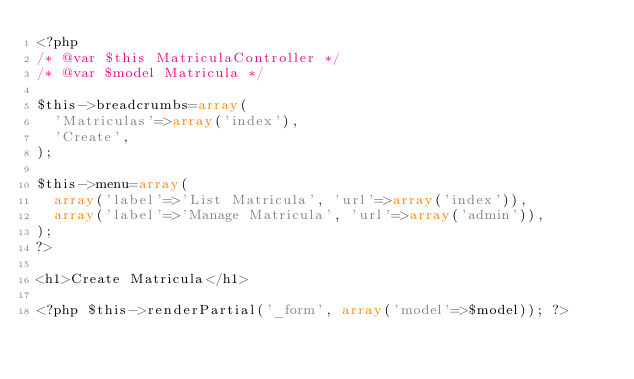Convert code to text. <code><loc_0><loc_0><loc_500><loc_500><_PHP_><?php
/* @var $this MatriculaController */
/* @var $model Matricula */

$this->breadcrumbs=array(
	'Matriculas'=>array('index'),
	'Create',
);

$this->menu=array(
	array('label'=>'List Matricula', 'url'=>array('index')),
	array('label'=>'Manage Matricula', 'url'=>array('admin')),
);
?>

<h1>Create Matricula</h1>

<?php $this->renderPartial('_form', array('model'=>$model)); ?></code> 